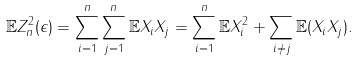<formula> <loc_0><loc_0><loc_500><loc_500>\mathbb { E } Z ^ { 2 } _ { n } ( \epsilon ) = \sum _ { i = 1 } ^ { n } \sum _ { j = 1 } ^ { n } \mathbb { E } X _ { i } X _ { j } = \sum _ { i = 1 } ^ { n } \mathbb { E } X ^ { 2 } _ { i } + \sum _ { i \neq j } \mathbb { E } ( X _ { i } X _ { j } ) .</formula> 